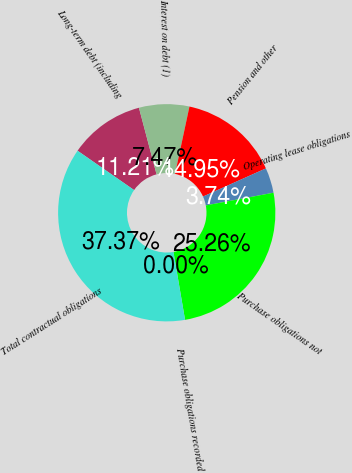Convert chart. <chart><loc_0><loc_0><loc_500><loc_500><pie_chart><fcel>Long-term debt (including<fcel>Interest on debt (1)<fcel>Pension and other<fcel>Operating lease obligations<fcel>Purchase obligations not<fcel>Purchase obligations recorded<fcel>Total contractual obligations<nl><fcel>11.21%<fcel>7.47%<fcel>14.95%<fcel>3.74%<fcel>25.26%<fcel>0.0%<fcel>37.37%<nl></chart> 